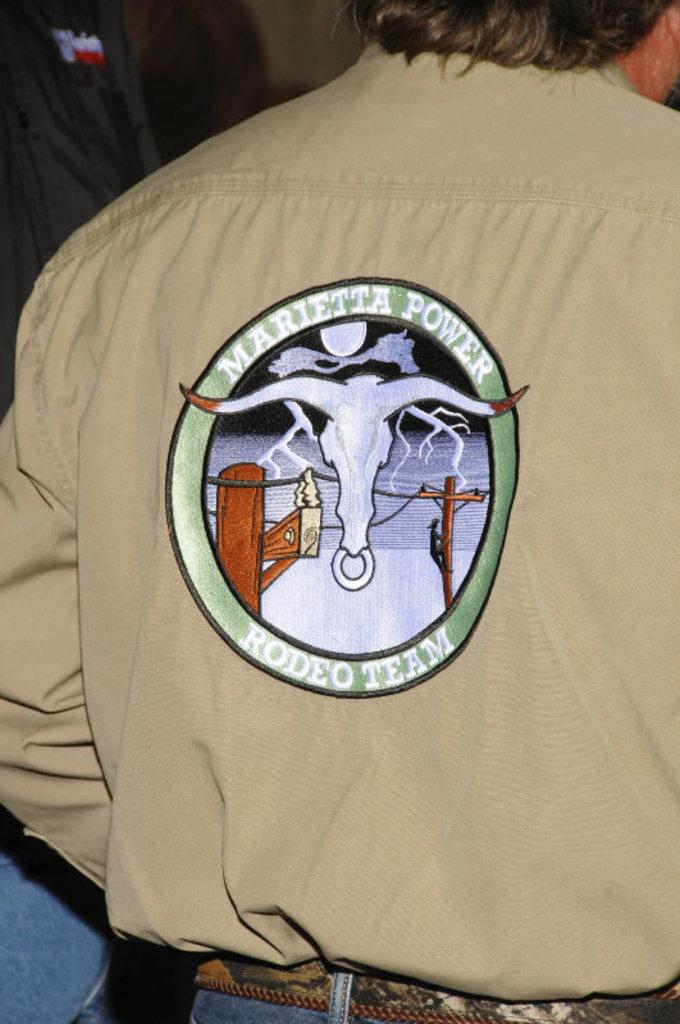Where is the rodeo teams locale?
Offer a very short reply. Marietta. 